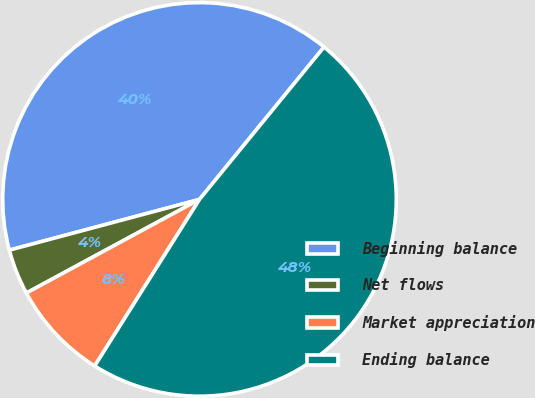<chart> <loc_0><loc_0><loc_500><loc_500><pie_chart><fcel>Beginning balance<fcel>Net flows<fcel>Market appreciation<fcel>Ending balance<nl><fcel>40.05%<fcel>3.74%<fcel>8.17%<fcel>48.03%<nl></chart> 